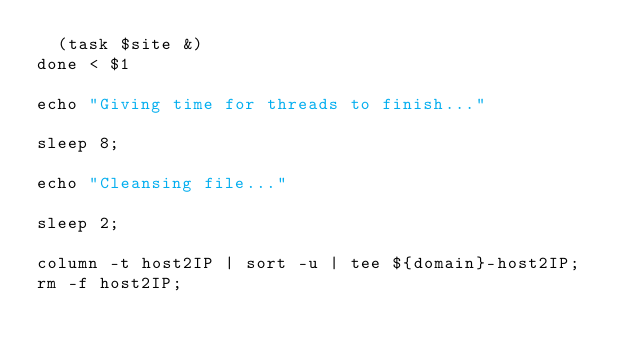Convert code to text. <code><loc_0><loc_0><loc_500><loc_500><_Bash_>	(task $site &)
done < $1

echo "Giving time for threads to finish..."

sleep 8;

echo "Cleansing file..."

sleep 2;

column -t host2IP | sort -u | tee ${domain}-host2IP;
rm -f host2IP;
</code> 